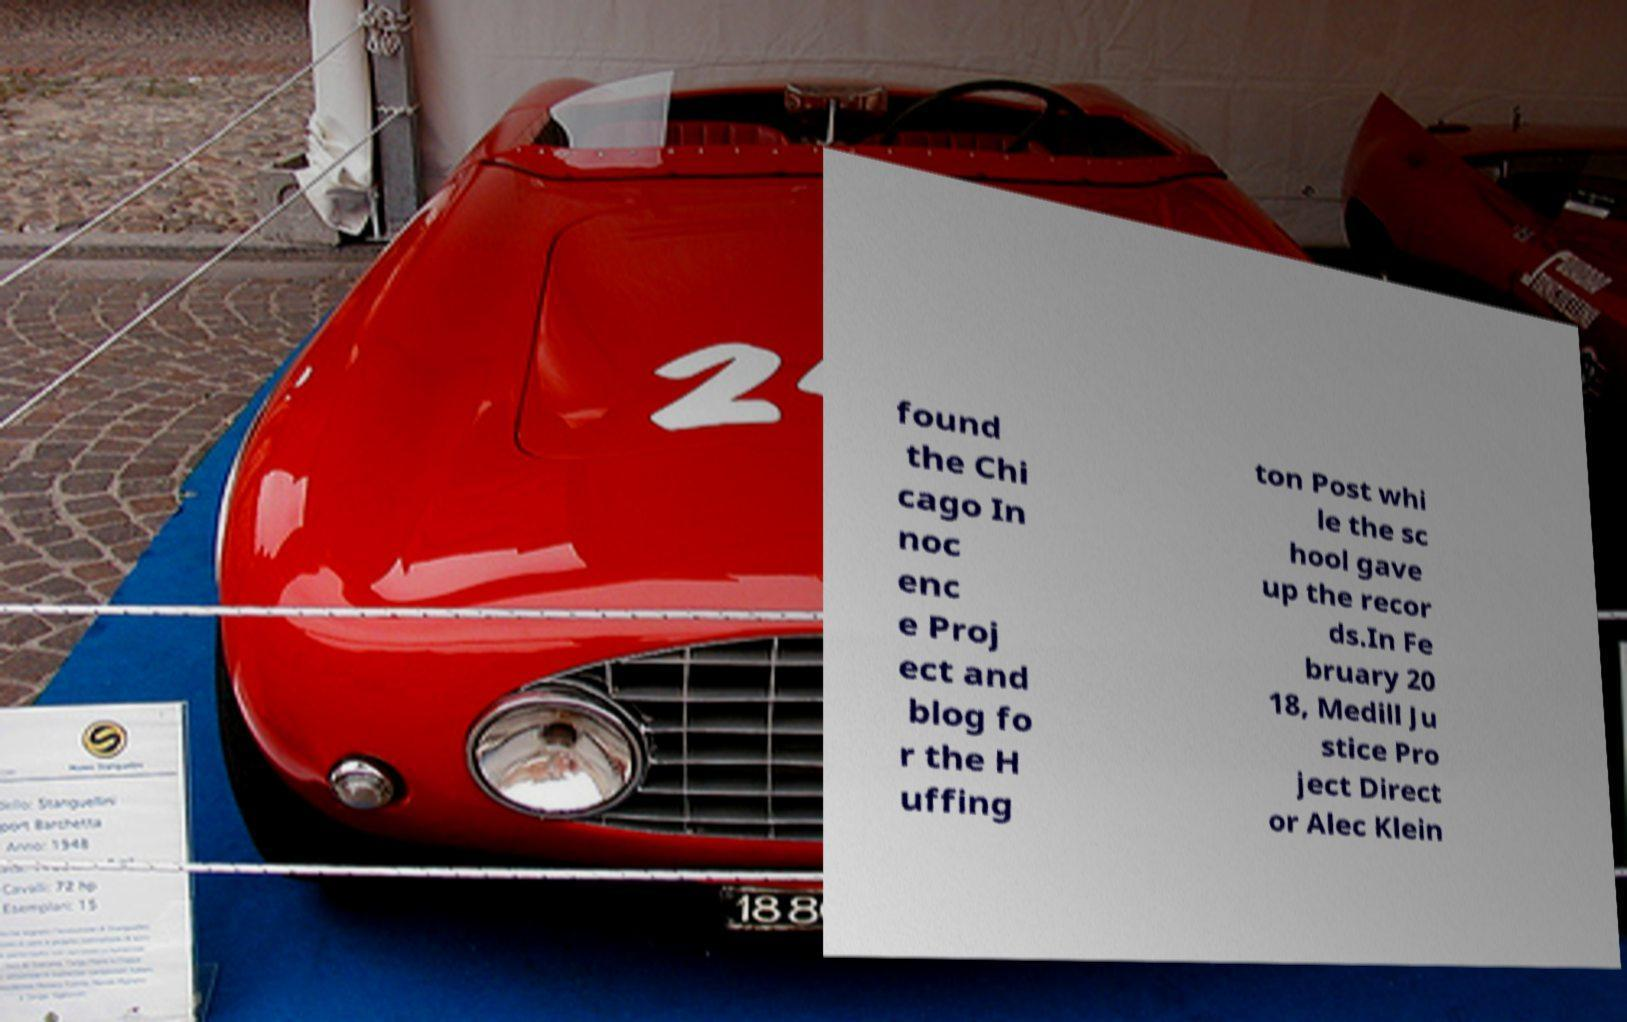I need the written content from this picture converted into text. Can you do that? found the Chi cago In noc enc e Proj ect and blog fo r the H uffing ton Post whi le the sc hool gave up the recor ds.In Fe bruary 20 18, Medill Ju stice Pro ject Direct or Alec Klein 